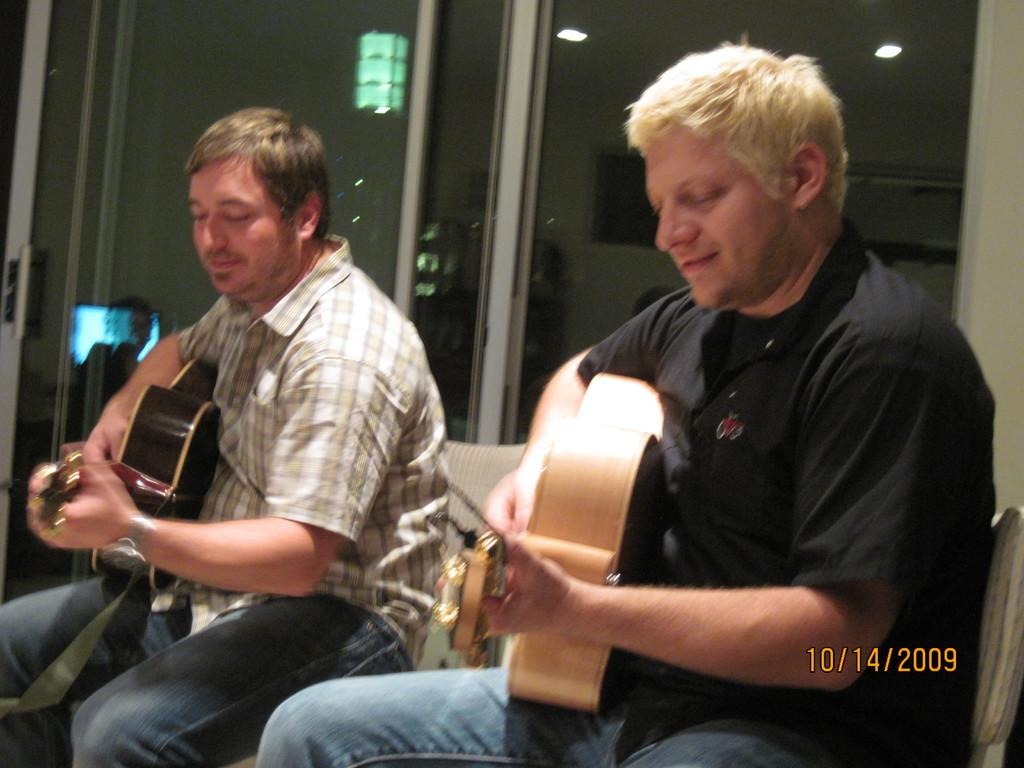How many people are in the image? There are two persons in the image. What are the persons doing in the image? The persons are sitting on chairs and playing musical instruments. Can you describe any objects in the image besides the musical instruments? Yes, there is a glass visible in the image. What is special about the glass in the image? The glass has a reflection of lights. What type of bear can be seen exchanging items with the persons in the image? There is no bear present in the image, and no exchange of items is taking place between the persons. 